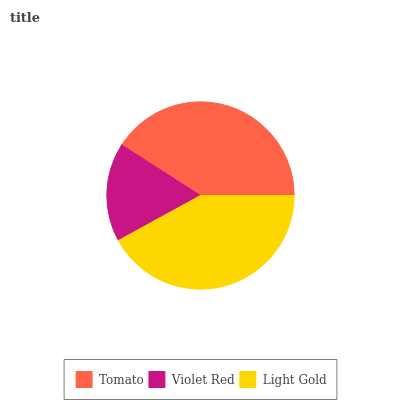Is Violet Red the minimum?
Answer yes or no. Yes. Is Light Gold the maximum?
Answer yes or no. Yes. Is Light Gold the minimum?
Answer yes or no. No. Is Violet Red the maximum?
Answer yes or no. No. Is Light Gold greater than Violet Red?
Answer yes or no. Yes. Is Violet Red less than Light Gold?
Answer yes or no. Yes. Is Violet Red greater than Light Gold?
Answer yes or no. No. Is Light Gold less than Violet Red?
Answer yes or no. No. Is Tomato the high median?
Answer yes or no. Yes. Is Tomato the low median?
Answer yes or no. Yes. Is Light Gold the high median?
Answer yes or no. No. Is Light Gold the low median?
Answer yes or no. No. 